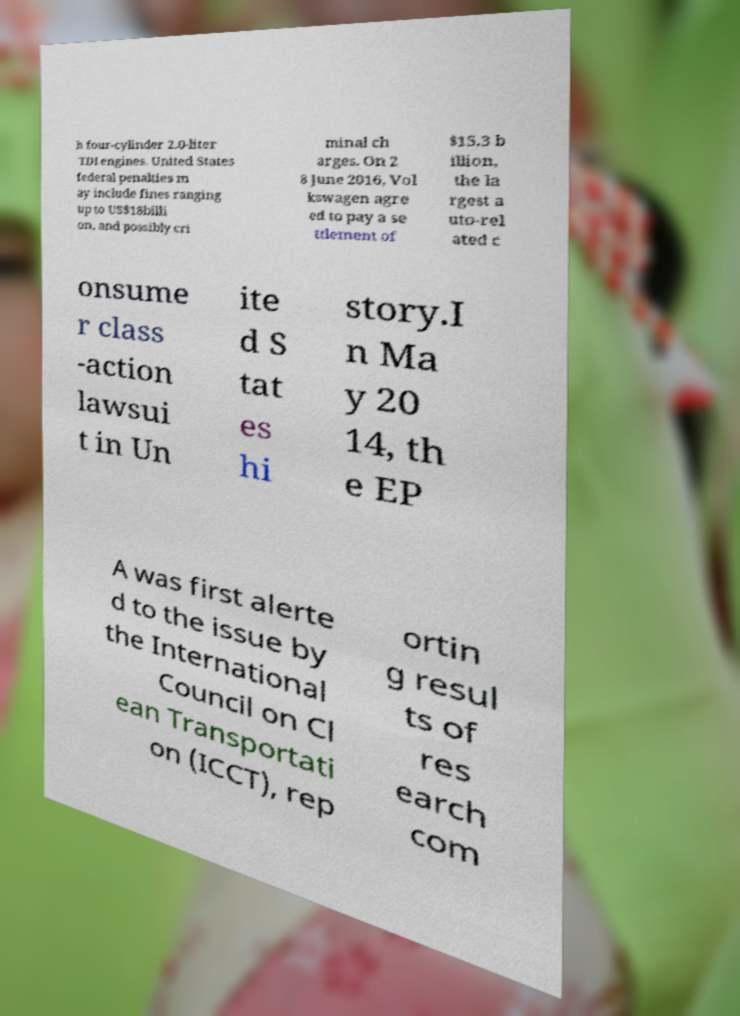Please identify and transcribe the text found in this image. h four-cylinder 2.0-liter TDI engines. United States federal penalties m ay include fines ranging up to US$18billi on, and possibly cri minal ch arges. On 2 8 June 2016, Vol kswagen agre ed to pay a se ttlement of $15.3 b illion, the la rgest a uto-rel ated c onsume r class -action lawsui t in Un ite d S tat es hi story.I n Ma y 20 14, th e EP A was first alerte d to the issue by the International Council on Cl ean Transportati on (ICCT), rep ortin g resul ts of res earch com 